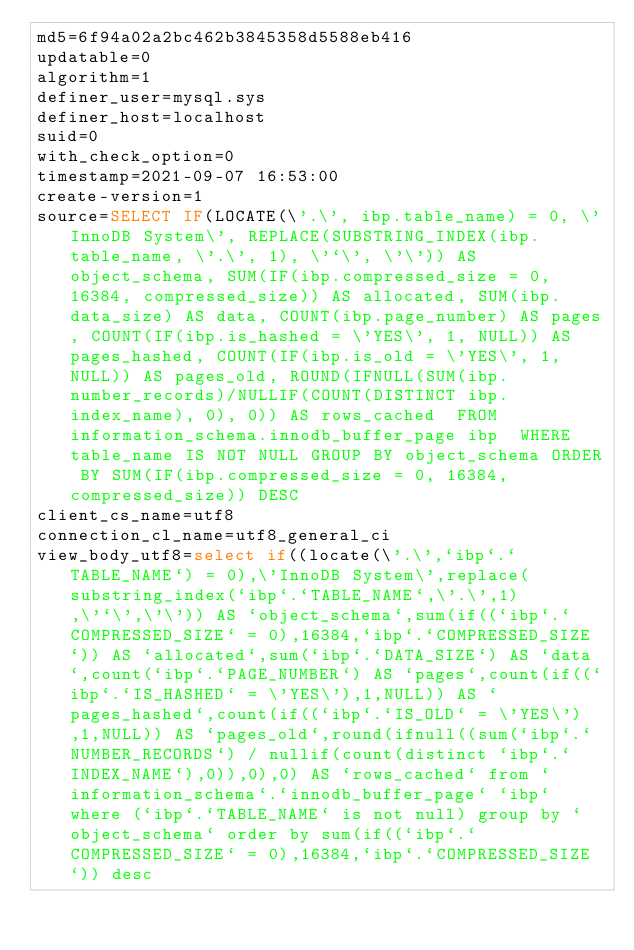<code> <loc_0><loc_0><loc_500><loc_500><_VisualBasic_>md5=6f94a02a2bc462b3845358d5588eb416
updatable=0
algorithm=1
definer_user=mysql.sys
definer_host=localhost
suid=0
with_check_option=0
timestamp=2021-09-07 16:53:00
create-version=1
source=SELECT IF(LOCATE(\'.\', ibp.table_name) = 0, \'InnoDB System\', REPLACE(SUBSTRING_INDEX(ibp.table_name, \'.\', 1), \'`\', \'\')) AS object_schema, SUM(IF(ibp.compressed_size = 0, 16384, compressed_size)) AS allocated, SUM(ibp.data_size) AS data, COUNT(ibp.page_number) AS pages, COUNT(IF(ibp.is_hashed = \'YES\', 1, NULL)) AS pages_hashed, COUNT(IF(ibp.is_old = \'YES\', 1, NULL)) AS pages_old, ROUND(IFNULL(SUM(ibp.number_records)/NULLIF(COUNT(DISTINCT ibp.index_name), 0), 0)) AS rows_cached  FROM information_schema.innodb_buffer_page ibp  WHERE table_name IS NOT NULL GROUP BY object_schema ORDER BY SUM(IF(ibp.compressed_size = 0, 16384, compressed_size)) DESC
client_cs_name=utf8
connection_cl_name=utf8_general_ci
view_body_utf8=select if((locate(\'.\',`ibp`.`TABLE_NAME`) = 0),\'InnoDB System\',replace(substring_index(`ibp`.`TABLE_NAME`,\'.\',1),\'`\',\'\')) AS `object_schema`,sum(if((`ibp`.`COMPRESSED_SIZE` = 0),16384,`ibp`.`COMPRESSED_SIZE`)) AS `allocated`,sum(`ibp`.`DATA_SIZE`) AS `data`,count(`ibp`.`PAGE_NUMBER`) AS `pages`,count(if((`ibp`.`IS_HASHED` = \'YES\'),1,NULL)) AS `pages_hashed`,count(if((`ibp`.`IS_OLD` = \'YES\'),1,NULL)) AS `pages_old`,round(ifnull((sum(`ibp`.`NUMBER_RECORDS`) / nullif(count(distinct `ibp`.`INDEX_NAME`),0)),0),0) AS `rows_cached` from `information_schema`.`innodb_buffer_page` `ibp` where (`ibp`.`TABLE_NAME` is not null) group by `object_schema` order by sum(if((`ibp`.`COMPRESSED_SIZE` = 0),16384,`ibp`.`COMPRESSED_SIZE`)) desc
</code> 